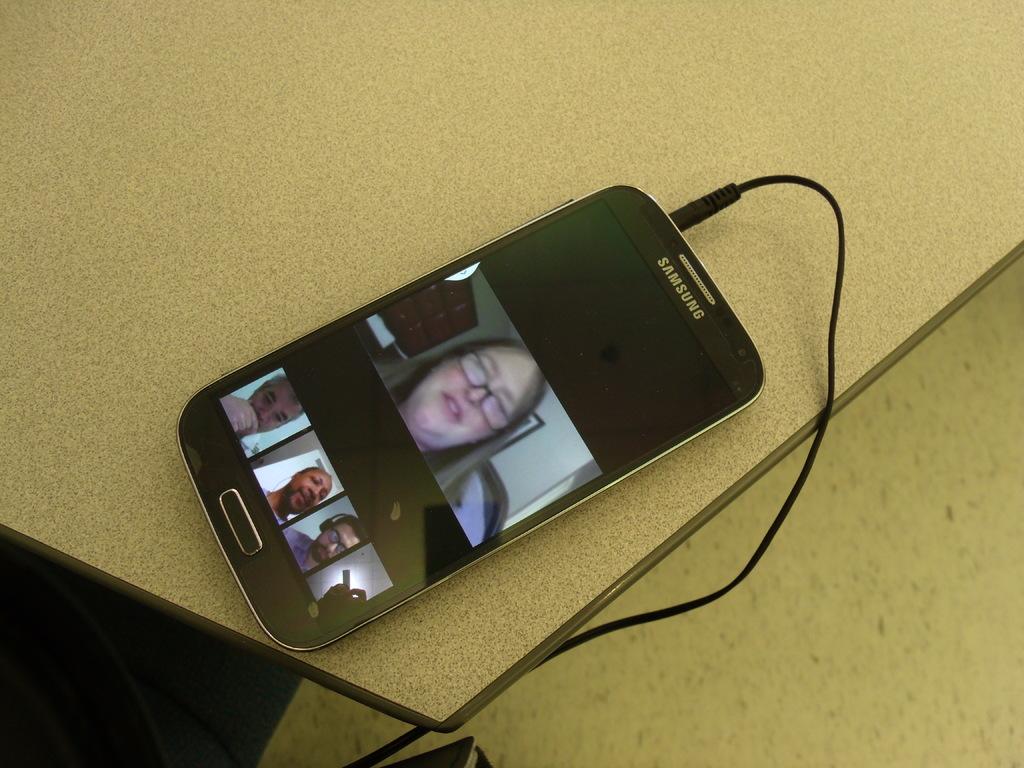What brand is the phone?
Keep it short and to the point. Samsung. 